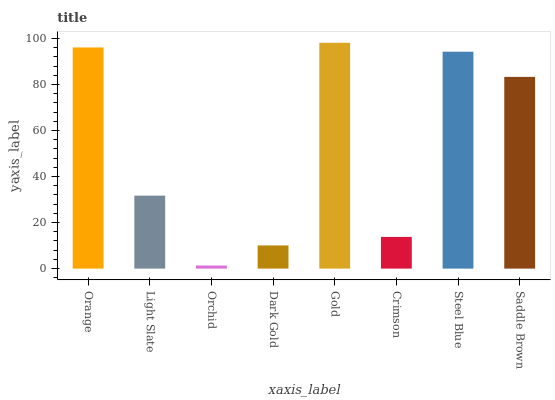Is Orchid the minimum?
Answer yes or no. Yes. Is Gold the maximum?
Answer yes or no. Yes. Is Light Slate the minimum?
Answer yes or no. No. Is Light Slate the maximum?
Answer yes or no. No. Is Orange greater than Light Slate?
Answer yes or no. Yes. Is Light Slate less than Orange?
Answer yes or no. Yes. Is Light Slate greater than Orange?
Answer yes or no. No. Is Orange less than Light Slate?
Answer yes or no. No. Is Saddle Brown the high median?
Answer yes or no. Yes. Is Light Slate the low median?
Answer yes or no. Yes. Is Crimson the high median?
Answer yes or no. No. Is Dark Gold the low median?
Answer yes or no. No. 